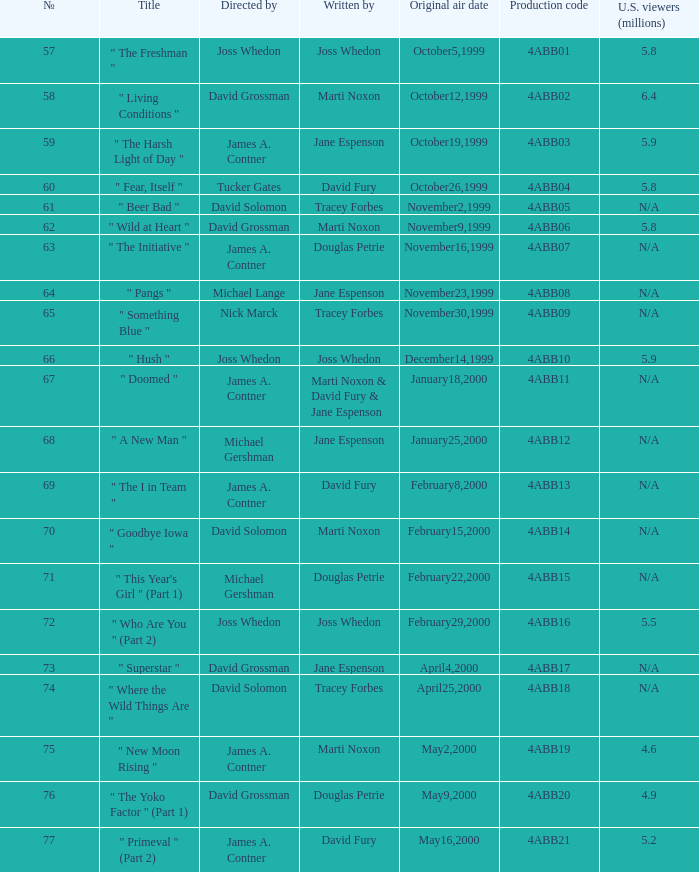Who wrote the episode which was directed by Nick Marck? Tracey Forbes. 